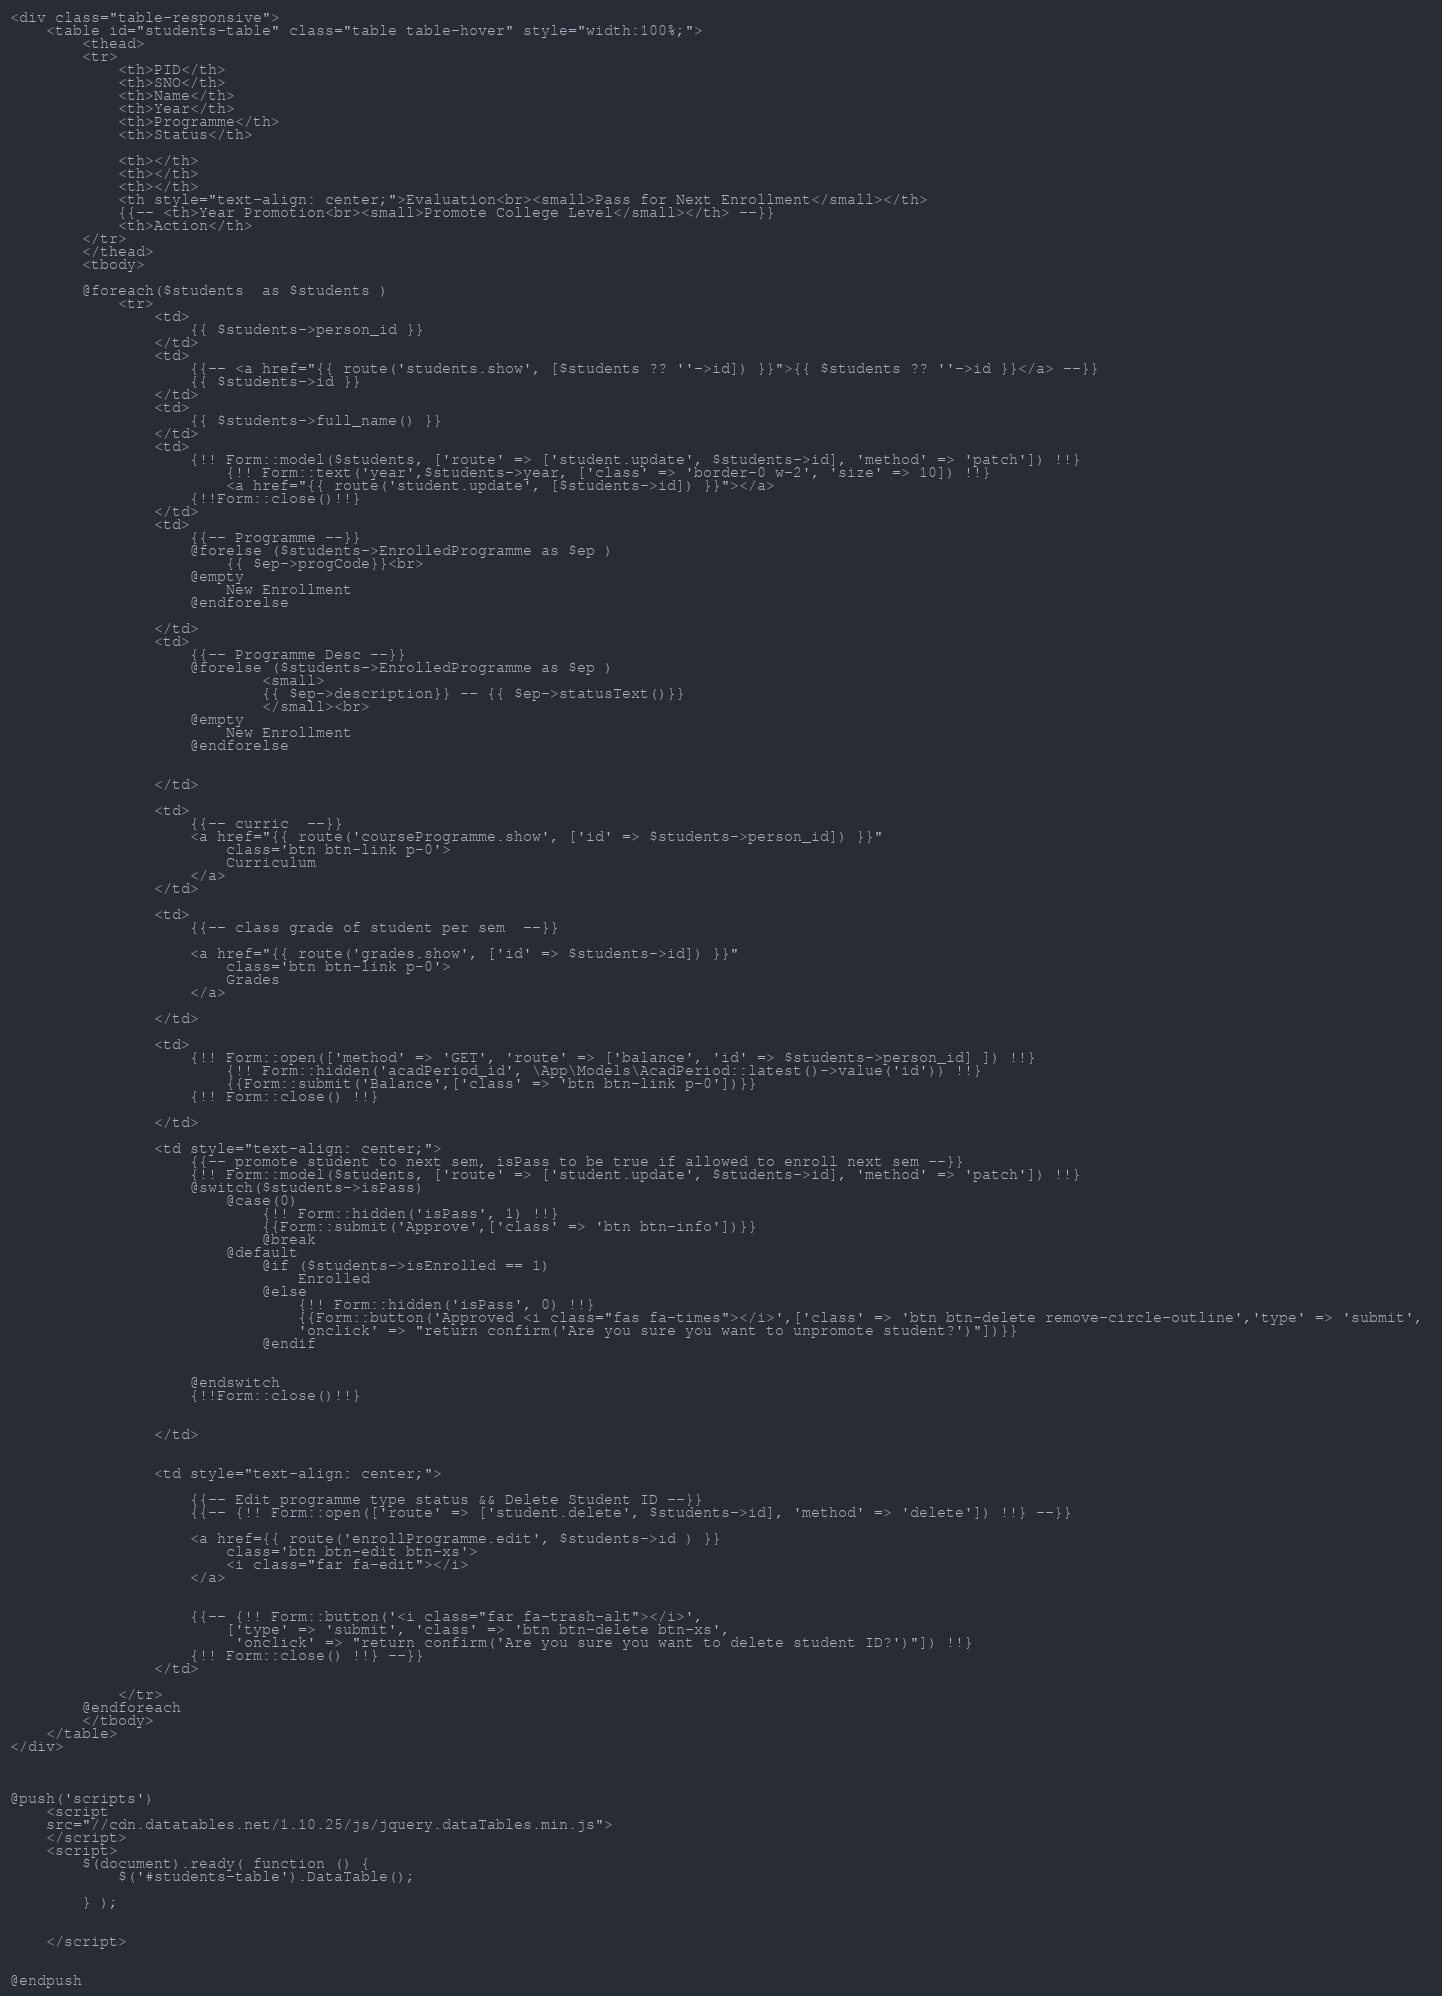Convert code to text. <code><loc_0><loc_0><loc_500><loc_500><_PHP_><div class="table-responsive">
    <table id="students-table" class="table table-hover" style="width:100%;">
        <thead>
        <tr>
            <th>PID</th>
            <th>SNO</th>
            <th>Name</th>
            <th>Year</th>
            <th>Programme</th>
            <th>Status</th>
            
            <th></th>
            <th></th>
            <th></th>
            <th style="text-align: center;">Evaluation<br><small>Pass for Next Enrollment</small></th>
            {{-- <th>Year Promotion<br><small>Promote College Level</small></th> --}}
            <th>Action</th>
        </tr>
        </thead>
        <tbody>
            
        @foreach($students  as $students )
            <tr>
                <td>
                    {{ $students->person_id }}
                </td>
                <td>
                    {{-- <a href="{{ route('students.show', [$students ?? ''->id]) }}">{{ $students ?? ''->id }}</a> --}}
                    {{ $students->id }}
                </td>
                <td>
                    {{ $students->full_name() }}
                </td>
                <td>
                    {!! Form::model($students, ['route' => ['student.update', $students->id], 'method' => 'patch']) !!}
                        {!! Form::text('year',$students->year, ['class' => 'border-0 w-2', 'size' => 10]) !!}
                        <a href="{{ route('student.update', [$students->id]) }}"></a>
                    {!!Form::close()!!} 
                </td>
                <td>
                    {{-- Programme --}}
                    @forelse ($students->EnrolledProgramme as $ep )  
                        {{ $ep->progCode}}<br>
                    @empty
                        New Enrollment
                    @endforelse
                
                </td>
                <td>
                    {{-- Programme Desc --}}
                    @forelse ($students->EnrolledProgramme as $ep )
                            <small> 
                            {{ $ep->description}} -- {{ $ep->statusText()}}
                            </small><br>
                    @empty
                        New Enrollment
                    @endforelse
                

                </td>
                
                <td>
                    {{-- curric  --}}
                    <a href="{{ route('courseProgramme.show', ['id' => $students->person_id]) }}"
                        class='btn btn-link p-0'>
                        Curriculum
                    </a> 
                </td>

                <td>
                    {{-- class grade of student per sem  --}}
                    
                    <a href="{{ route('grades.show', ['id' => $students->id]) }}"
                        class='btn btn-link p-0'>
                        Grades
                    </a> 

                </td>

                <td>
                    {!! Form::open(['method' => 'GET', 'route' => ['balance', 'id' => $students->person_id] ]) !!}
                        {!! Form::hidden('acadPeriod_id', \App\Models\AcadPeriod::latest()->value('id')) !!}
                        {{Form::submit('Balance',['class' => 'btn btn-link p-0'])}}
                    {!! Form::close() !!}
                    
                </td>
                
                <td style="text-align: center;">
                    {{-- promote student to next sem, isPass to be true if allowed to enroll next sem --}}
                    {!! Form::model($students, ['route' => ['student.update', $students->id], 'method' => 'patch']) !!}
                    @switch($students->isPass)
                        @case(0)
                            {!! Form::hidden('isPass', 1) !!}
                            {{Form::submit('Approve',['class' => 'btn btn-info'])}}
                            @break
                        @default
                            @if ($students->isEnrolled == 1)
                                Enrolled
                            @else
                                {!! Form::hidden('isPass', 0) !!}
                                {{Form::button('Approved <i class="fas fa-times"></i>',['class' => 'btn btn-delete remove-circle-outline','type' => 'submit', 
                                'onclick' => "return confirm('Are you sure you want to unpromote student?')"])}}
                            @endif
                               
                            
                    @endswitch
                    {!!Form::close()!!} 
                        
                    
                </td>

                
                <td style="text-align: center;">

                    {{-- Edit programme type status && Delete Student ID --}}
                    {{-- {!! Form::open(['route' => ['student.delete', $students->id], 'method' => 'delete']) !!} --}}
                    
                    <a href={{ route('enrollProgramme.edit', $students->id ) }}
                        class='btn btn-edit btn-xs'>
                        <i class="far fa-edit"></i>
                    </a>
                    
                    
                    {{-- {!! Form::button('<i class="far fa-trash-alt"></i>', 
                        ['type' => 'submit', 'class' => 'btn btn-delete btn-xs',
                         'onclick' => "return confirm('Are you sure you want to delete student ID?')"]) !!}
                    {!! Form::close() !!} --}}
                </td>
               
            </tr>
        @endforeach
        </tbody>
    </table>
</div>



@push('scripts')
    <script
    src="//cdn.datatables.net/1.10.25/js/jquery.dataTables.min.js">
    </script>
    <script>
        $(document).ready( function () {
            $('#students-table').DataTable();
           
        } );

        
    </script>

    
@endpush
</code> 